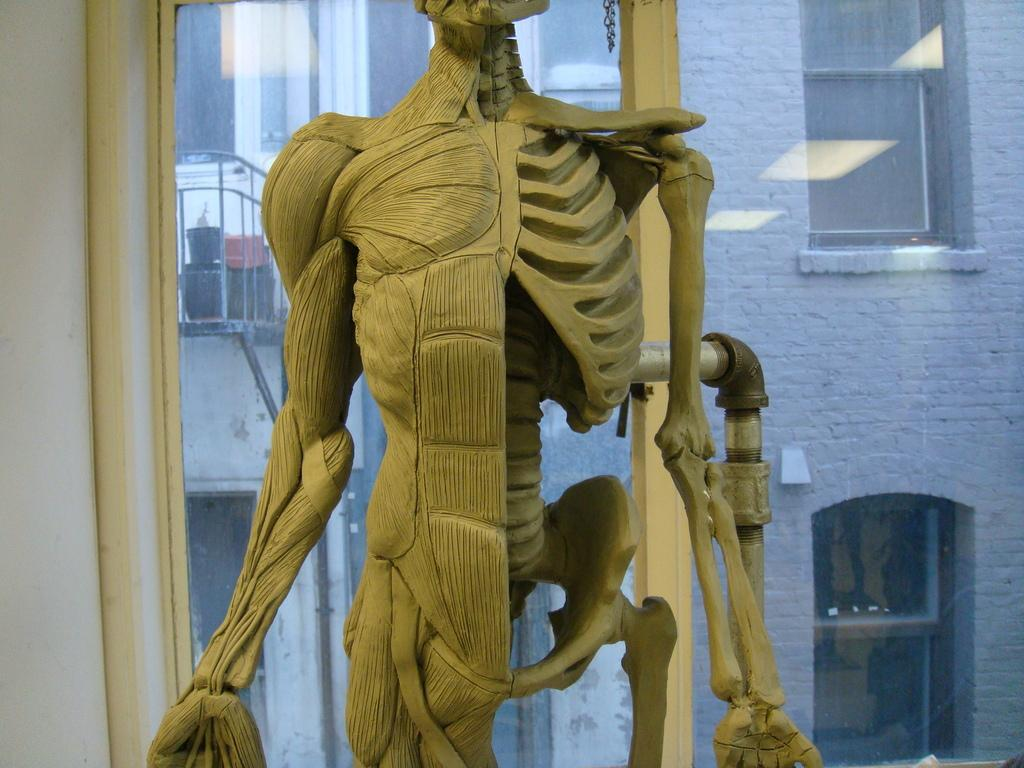What is the main subject of the image? There is a skeleton in the image. What else can be seen in the image besides the skeleton? There is a pipe, a wall, and a window visible in the image. What is visible through the window in the image? Through the window, there is a building, windows, a railing, and other objects visible. What type of prose is being recited by the skeleton in the image? There is no indication in the image that the skeleton is reciting any prose or engaging in any form of communication. 